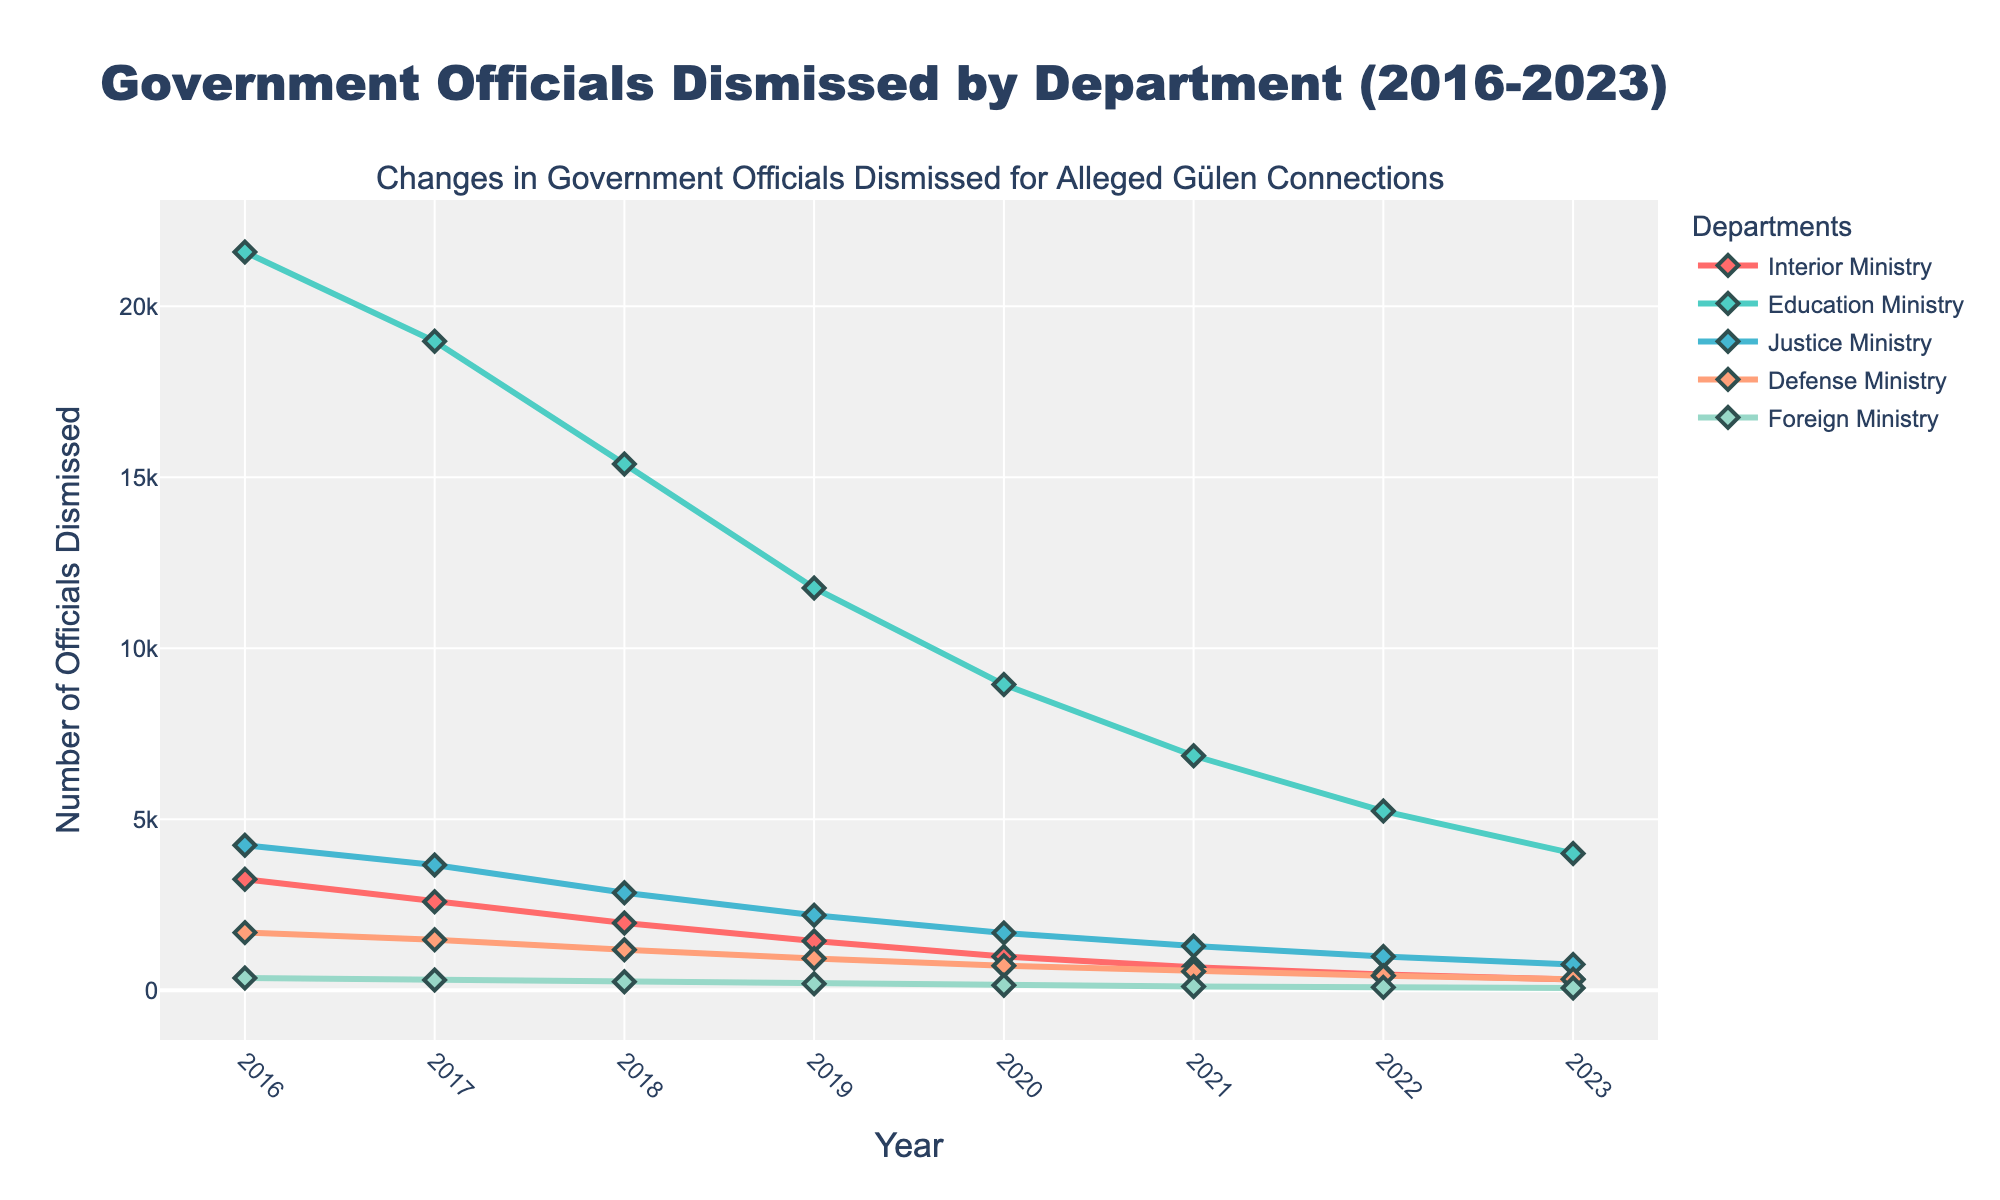What year saw the highest number of dismissals in the Education Ministry? The point on the chart with the highest y-axis value for the Education Ministry (green line) corresponds to the year 2016 with 21,583 dismissals.
Answer: 2016 Which department had the least number of officials dismissed in 2023? By comparing the points for 2023, the Foreign Ministry (purple line) has the lowest value with 64 dismissals.
Answer: Foreign Ministry How did the number of dismissals in the Interior Ministry change from 2016 to 2023? The number decreased from 3,245 in 2016 to 314 in 2023, showing a general downward trend.
Answer: Decreased What's the average number of officials dismissed in the Defense Ministry throughout the years 2016 to 2023? Adding the numbers (1684+1472+1183+926+714+548+421+323) and dividing by 8 years results in an average. The sum is 7271; average is 7271 / 8 = 908.88.
Answer: 909 In which year did the Justice Ministry experience the biggest drop in dismissals compared to the previous year? Comparing year-to-year drops, the biggest drop is from 2017 to 2018, decreasing from 3659 to 2847 (812 dismissals).
Answer: 2018 Which department shows a consistent decline in dismissals every year from 2016 to 2023? Observing the chart, the Education Ministry (green line) shows a consistent yearly decline without any reversals.
Answer: Education Ministry How many more officials were dismissed in the Interior Ministry compared to the Foreign Ministry in 2017? Subtracting the Foreign Ministry value from the Interior Ministry value for 2017 (2587 - 298), results in a difference of 2289.
Answer: 2289 If we sum the officials dismissed in the Justice Ministry and Defense Ministry in 2022, what is the total? Adding the numbers for 2022 (987 for Justice + 421 for Defense), the total is 1408.
Answer: 1408 Which ministry had a faster rate of decline in officials dismissed from 2016 to 2023: the Interior Ministry or the Education Ministry? The Interior Ministry went from 3245 to 314 (a decline of 2931), and the Education Ministry from 21583 to 3998 (a decline of 17585). The rate of decline is greater for the Education Ministry.
Answer: Education Ministry 